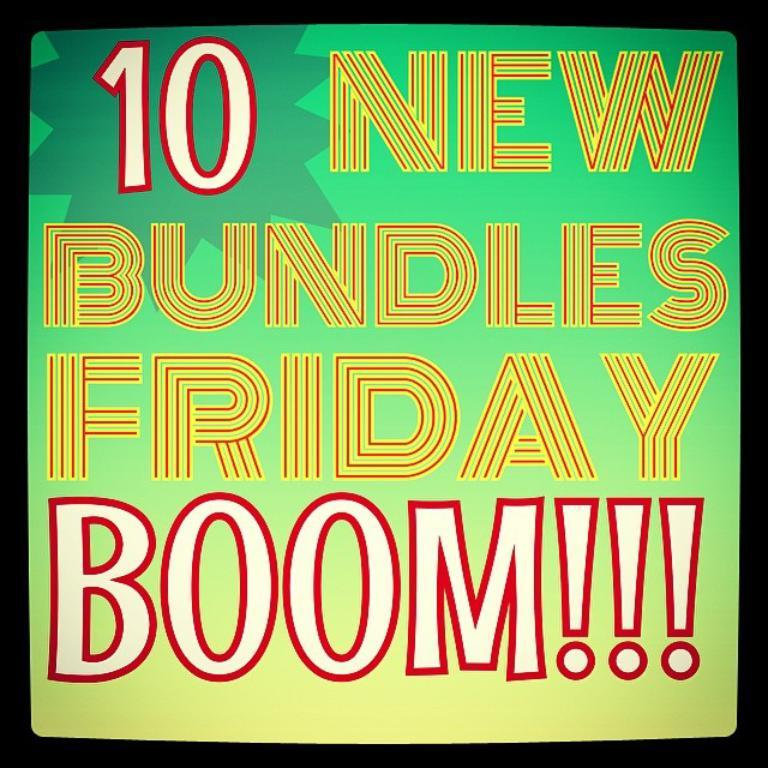<image>
Describe the image concisely. An ad claims 10 new bundles on Friday. 